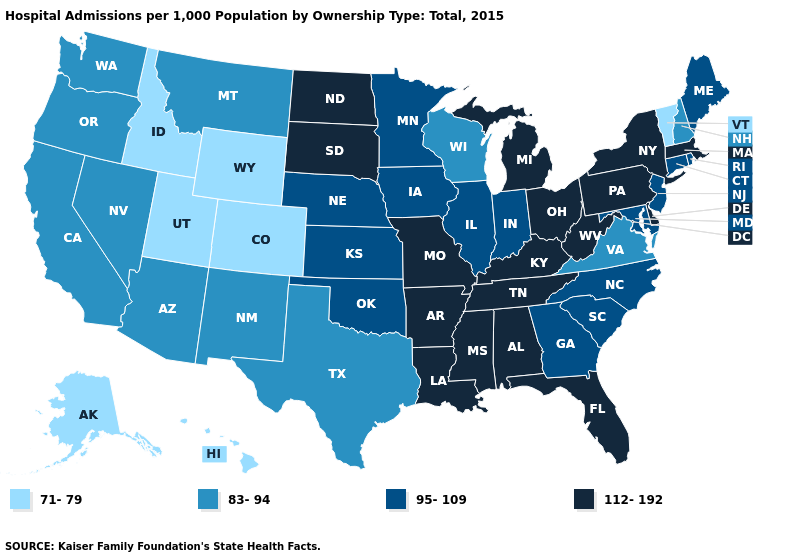Does Idaho have the lowest value in the USA?
Be succinct. Yes. What is the highest value in the USA?
Answer briefly. 112-192. Name the states that have a value in the range 112-192?
Short answer required. Alabama, Arkansas, Delaware, Florida, Kentucky, Louisiana, Massachusetts, Michigan, Mississippi, Missouri, New York, North Dakota, Ohio, Pennsylvania, South Dakota, Tennessee, West Virginia. What is the value of Georgia?
Short answer required. 95-109. Name the states that have a value in the range 112-192?
Write a very short answer. Alabama, Arkansas, Delaware, Florida, Kentucky, Louisiana, Massachusetts, Michigan, Mississippi, Missouri, New York, North Dakota, Ohio, Pennsylvania, South Dakota, Tennessee, West Virginia. What is the value of Idaho?
Concise answer only. 71-79. What is the lowest value in the MidWest?
Answer briefly. 83-94. Among the states that border Iowa , which have the highest value?
Answer briefly. Missouri, South Dakota. What is the value of Louisiana?
Write a very short answer. 112-192. Which states have the lowest value in the MidWest?
Answer briefly. Wisconsin. Does the first symbol in the legend represent the smallest category?
Concise answer only. Yes. What is the value of Mississippi?
Answer briefly. 112-192. Name the states that have a value in the range 112-192?
Short answer required. Alabama, Arkansas, Delaware, Florida, Kentucky, Louisiana, Massachusetts, Michigan, Mississippi, Missouri, New York, North Dakota, Ohio, Pennsylvania, South Dakota, Tennessee, West Virginia. What is the highest value in states that border Massachusetts?
Quick response, please. 112-192. What is the value of Georgia?
Answer briefly. 95-109. 